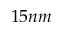<formula> <loc_0><loc_0><loc_500><loc_500>1 5 n m</formula> 